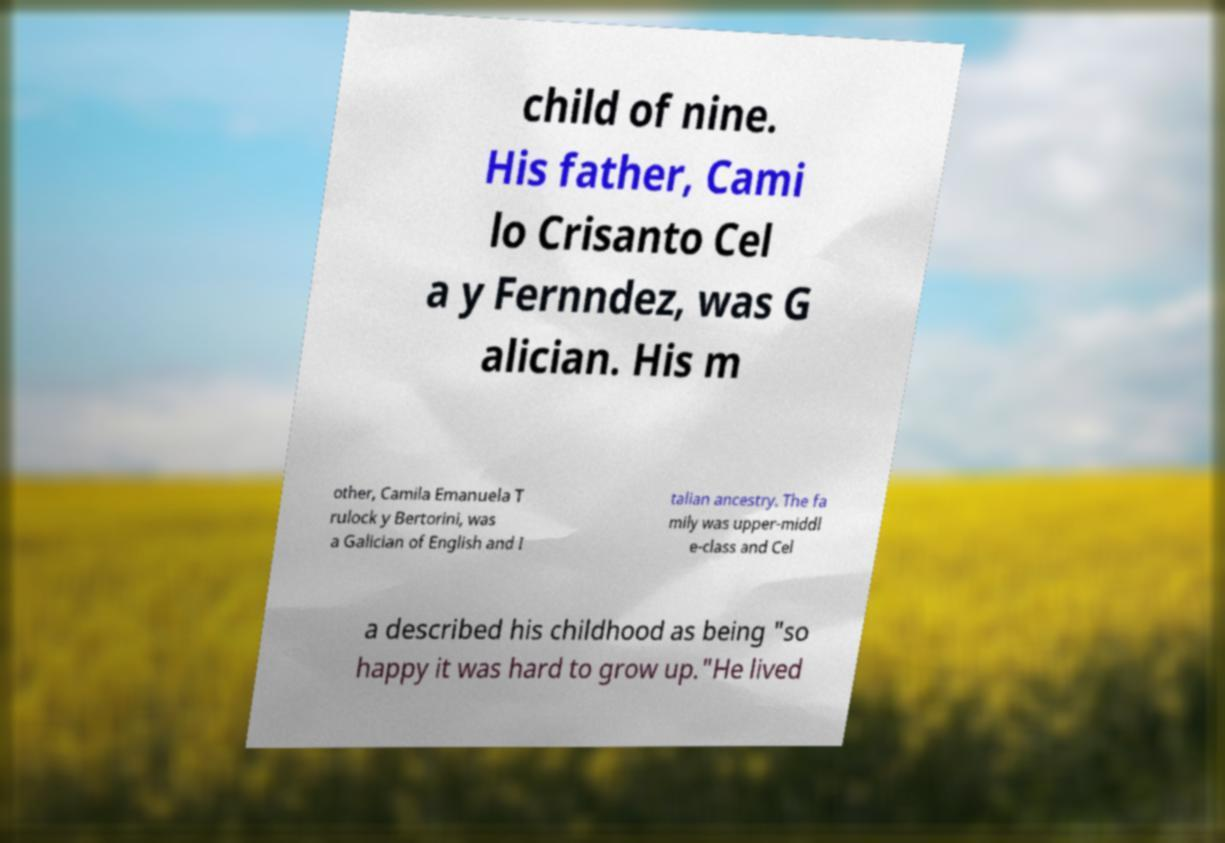What messages or text are displayed in this image? I need them in a readable, typed format. child of nine. His father, Cami lo Crisanto Cel a y Fernndez, was G alician. His m other, Camila Emanuela T rulock y Bertorini, was a Galician of English and I talian ancestry. The fa mily was upper-middl e-class and Cel a described his childhood as being "so happy it was hard to grow up."He lived 